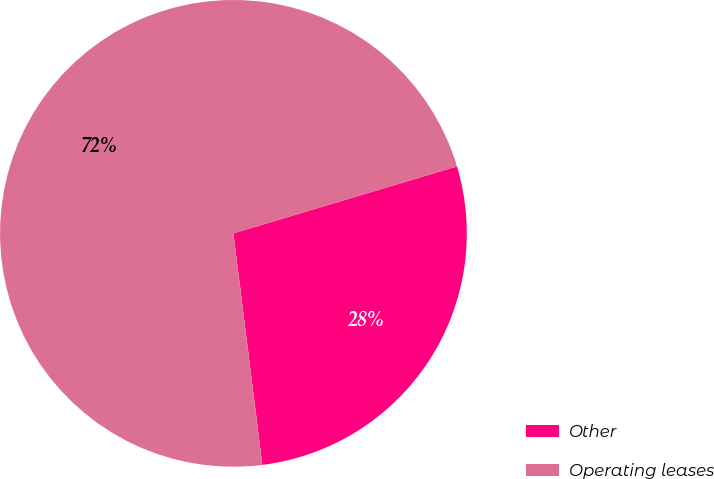Convert chart to OTSL. <chart><loc_0><loc_0><loc_500><loc_500><pie_chart><fcel>Other<fcel>Operating leases<nl><fcel>27.65%<fcel>72.35%<nl></chart> 